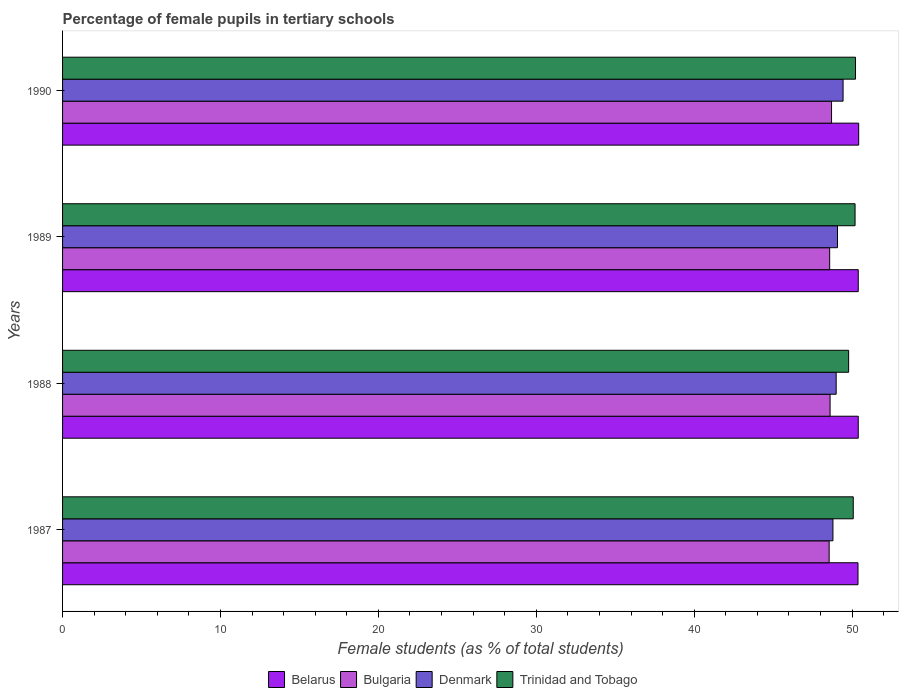How many different coloured bars are there?
Make the answer very short. 4. How many groups of bars are there?
Your answer should be very brief. 4. Are the number of bars on each tick of the Y-axis equal?
Your response must be concise. Yes. How many bars are there on the 4th tick from the top?
Provide a succinct answer. 4. What is the label of the 2nd group of bars from the top?
Offer a terse response. 1989. What is the percentage of female pupils in tertiary schools in Denmark in 1989?
Your response must be concise. 49.07. Across all years, what is the maximum percentage of female pupils in tertiary schools in Denmark?
Offer a very short reply. 49.43. Across all years, what is the minimum percentage of female pupils in tertiary schools in Denmark?
Keep it short and to the point. 48.79. In which year was the percentage of female pupils in tertiary schools in Belarus minimum?
Ensure brevity in your answer.  1987. What is the total percentage of female pupils in tertiary schools in Belarus in the graph?
Offer a very short reply. 201.57. What is the difference between the percentage of female pupils in tertiary schools in Denmark in 1988 and that in 1989?
Make the answer very short. -0.08. What is the difference between the percentage of female pupils in tertiary schools in Trinidad and Tobago in 1987 and the percentage of female pupils in tertiary schools in Bulgaria in 1988?
Keep it short and to the point. 1.47. What is the average percentage of female pupils in tertiary schools in Trinidad and Tobago per year?
Keep it short and to the point. 50.06. In the year 1988, what is the difference between the percentage of female pupils in tertiary schools in Denmark and percentage of female pupils in tertiary schools in Trinidad and Tobago?
Provide a short and direct response. -0.79. What is the ratio of the percentage of female pupils in tertiary schools in Belarus in 1989 to that in 1990?
Your response must be concise. 1. Is the percentage of female pupils in tertiary schools in Belarus in 1989 less than that in 1990?
Offer a very short reply. Yes. What is the difference between the highest and the second highest percentage of female pupils in tertiary schools in Bulgaria?
Give a very brief answer. 0.09. What is the difference between the highest and the lowest percentage of female pupils in tertiary schools in Belarus?
Ensure brevity in your answer.  0.04. Is it the case that in every year, the sum of the percentage of female pupils in tertiary schools in Belarus and percentage of female pupils in tertiary schools in Trinidad and Tobago is greater than the sum of percentage of female pupils in tertiary schools in Denmark and percentage of female pupils in tertiary schools in Bulgaria?
Offer a terse response. No. What does the 4th bar from the top in 1990 represents?
Your answer should be very brief. Belarus. What does the 1st bar from the bottom in 1987 represents?
Your answer should be very brief. Belarus. Is it the case that in every year, the sum of the percentage of female pupils in tertiary schools in Belarus and percentage of female pupils in tertiary schools in Trinidad and Tobago is greater than the percentage of female pupils in tertiary schools in Bulgaria?
Give a very brief answer. Yes. How many bars are there?
Your answer should be very brief. 16. Are all the bars in the graph horizontal?
Offer a very short reply. Yes. How many years are there in the graph?
Provide a short and direct response. 4. What is the difference between two consecutive major ticks on the X-axis?
Make the answer very short. 10. Are the values on the major ticks of X-axis written in scientific E-notation?
Your answer should be very brief. No. Does the graph contain any zero values?
Your answer should be very brief. No. Does the graph contain grids?
Your response must be concise. No. What is the title of the graph?
Provide a short and direct response. Percentage of female pupils in tertiary schools. What is the label or title of the X-axis?
Provide a succinct answer. Female students (as % of total students). What is the label or title of the Y-axis?
Provide a short and direct response. Years. What is the Female students (as % of total students) of Belarus in 1987?
Your answer should be compact. 50.37. What is the Female students (as % of total students) of Bulgaria in 1987?
Your answer should be compact. 48.55. What is the Female students (as % of total students) in Denmark in 1987?
Offer a very short reply. 48.79. What is the Female students (as % of total students) in Trinidad and Tobago in 1987?
Make the answer very short. 50.07. What is the Female students (as % of total students) in Belarus in 1988?
Keep it short and to the point. 50.39. What is the Female students (as % of total students) of Bulgaria in 1988?
Keep it short and to the point. 48.6. What is the Female students (as % of total students) of Denmark in 1988?
Offer a terse response. 48.99. What is the Female students (as % of total students) in Trinidad and Tobago in 1988?
Your answer should be compact. 49.78. What is the Female students (as % of total students) in Belarus in 1989?
Your response must be concise. 50.39. What is the Female students (as % of total students) in Bulgaria in 1989?
Give a very brief answer. 48.58. What is the Female students (as % of total students) of Denmark in 1989?
Offer a very short reply. 49.07. What is the Female students (as % of total students) of Trinidad and Tobago in 1989?
Ensure brevity in your answer.  50.19. What is the Female students (as % of total students) in Belarus in 1990?
Your response must be concise. 50.42. What is the Female students (as % of total students) of Bulgaria in 1990?
Your answer should be compact. 48.7. What is the Female students (as % of total students) in Denmark in 1990?
Give a very brief answer. 49.43. What is the Female students (as % of total students) in Trinidad and Tobago in 1990?
Offer a terse response. 50.22. Across all years, what is the maximum Female students (as % of total students) of Belarus?
Provide a short and direct response. 50.42. Across all years, what is the maximum Female students (as % of total students) of Bulgaria?
Ensure brevity in your answer.  48.7. Across all years, what is the maximum Female students (as % of total students) of Denmark?
Your response must be concise. 49.43. Across all years, what is the maximum Female students (as % of total students) in Trinidad and Tobago?
Keep it short and to the point. 50.22. Across all years, what is the minimum Female students (as % of total students) of Belarus?
Keep it short and to the point. 50.37. Across all years, what is the minimum Female students (as % of total students) in Bulgaria?
Provide a short and direct response. 48.55. Across all years, what is the minimum Female students (as % of total students) of Denmark?
Make the answer very short. 48.79. Across all years, what is the minimum Female students (as % of total students) in Trinidad and Tobago?
Provide a short and direct response. 49.78. What is the total Female students (as % of total students) in Belarus in the graph?
Keep it short and to the point. 201.57. What is the total Female students (as % of total students) of Bulgaria in the graph?
Provide a short and direct response. 194.43. What is the total Female students (as % of total students) in Denmark in the graph?
Offer a terse response. 196.28. What is the total Female students (as % of total students) of Trinidad and Tobago in the graph?
Your response must be concise. 200.25. What is the difference between the Female students (as % of total students) in Belarus in 1987 and that in 1988?
Keep it short and to the point. -0.02. What is the difference between the Female students (as % of total students) in Bulgaria in 1987 and that in 1988?
Your answer should be very brief. -0.06. What is the difference between the Female students (as % of total students) of Denmark in 1987 and that in 1988?
Provide a short and direct response. -0.2. What is the difference between the Female students (as % of total students) in Trinidad and Tobago in 1987 and that in 1988?
Offer a very short reply. 0.29. What is the difference between the Female students (as % of total students) of Belarus in 1987 and that in 1989?
Keep it short and to the point. -0.02. What is the difference between the Female students (as % of total students) of Bulgaria in 1987 and that in 1989?
Your answer should be compact. -0.03. What is the difference between the Female students (as % of total students) of Denmark in 1987 and that in 1989?
Give a very brief answer. -0.29. What is the difference between the Female students (as % of total students) in Trinidad and Tobago in 1987 and that in 1989?
Your answer should be very brief. -0.12. What is the difference between the Female students (as % of total students) of Belarus in 1987 and that in 1990?
Your answer should be compact. -0.04. What is the difference between the Female students (as % of total students) of Bulgaria in 1987 and that in 1990?
Provide a short and direct response. -0.15. What is the difference between the Female students (as % of total students) of Denmark in 1987 and that in 1990?
Your answer should be very brief. -0.64. What is the difference between the Female students (as % of total students) of Trinidad and Tobago in 1987 and that in 1990?
Offer a very short reply. -0.14. What is the difference between the Female students (as % of total students) in Belarus in 1988 and that in 1989?
Make the answer very short. -0. What is the difference between the Female students (as % of total students) in Bulgaria in 1988 and that in 1989?
Provide a short and direct response. 0.03. What is the difference between the Female students (as % of total students) of Denmark in 1988 and that in 1989?
Ensure brevity in your answer.  -0.08. What is the difference between the Female students (as % of total students) in Trinidad and Tobago in 1988 and that in 1989?
Provide a succinct answer. -0.41. What is the difference between the Female students (as % of total students) in Belarus in 1988 and that in 1990?
Give a very brief answer. -0.03. What is the difference between the Female students (as % of total students) in Bulgaria in 1988 and that in 1990?
Ensure brevity in your answer.  -0.09. What is the difference between the Female students (as % of total students) of Denmark in 1988 and that in 1990?
Provide a succinct answer. -0.44. What is the difference between the Female students (as % of total students) in Trinidad and Tobago in 1988 and that in 1990?
Provide a short and direct response. -0.44. What is the difference between the Female students (as % of total students) in Belarus in 1989 and that in 1990?
Your answer should be very brief. -0.03. What is the difference between the Female students (as % of total students) in Bulgaria in 1989 and that in 1990?
Keep it short and to the point. -0.12. What is the difference between the Female students (as % of total students) of Denmark in 1989 and that in 1990?
Provide a succinct answer. -0.35. What is the difference between the Female students (as % of total students) of Trinidad and Tobago in 1989 and that in 1990?
Keep it short and to the point. -0.03. What is the difference between the Female students (as % of total students) of Belarus in 1987 and the Female students (as % of total students) of Bulgaria in 1988?
Give a very brief answer. 1.77. What is the difference between the Female students (as % of total students) in Belarus in 1987 and the Female students (as % of total students) in Denmark in 1988?
Provide a succinct answer. 1.38. What is the difference between the Female students (as % of total students) in Belarus in 1987 and the Female students (as % of total students) in Trinidad and Tobago in 1988?
Offer a very short reply. 0.59. What is the difference between the Female students (as % of total students) in Bulgaria in 1987 and the Female students (as % of total students) in Denmark in 1988?
Make the answer very short. -0.44. What is the difference between the Female students (as % of total students) in Bulgaria in 1987 and the Female students (as % of total students) in Trinidad and Tobago in 1988?
Give a very brief answer. -1.23. What is the difference between the Female students (as % of total students) of Denmark in 1987 and the Female students (as % of total students) of Trinidad and Tobago in 1988?
Your response must be concise. -0.99. What is the difference between the Female students (as % of total students) of Belarus in 1987 and the Female students (as % of total students) of Bulgaria in 1989?
Your answer should be very brief. 1.79. What is the difference between the Female students (as % of total students) in Belarus in 1987 and the Female students (as % of total students) in Denmark in 1989?
Keep it short and to the point. 1.3. What is the difference between the Female students (as % of total students) in Belarus in 1987 and the Female students (as % of total students) in Trinidad and Tobago in 1989?
Provide a short and direct response. 0.19. What is the difference between the Female students (as % of total students) of Bulgaria in 1987 and the Female students (as % of total students) of Denmark in 1989?
Your answer should be very brief. -0.53. What is the difference between the Female students (as % of total students) in Bulgaria in 1987 and the Female students (as % of total students) in Trinidad and Tobago in 1989?
Ensure brevity in your answer.  -1.64. What is the difference between the Female students (as % of total students) of Denmark in 1987 and the Female students (as % of total students) of Trinidad and Tobago in 1989?
Your answer should be very brief. -1.4. What is the difference between the Female students (as % of total students) in Belarus in 1987 and the Female students (as % of total students) in Bulgaria in 1990?
Make the answer very short. 1.68. What is the difference between the Female students (as % of total students) in Belarus in 1987 and the Female students (as % of total students) in Denmark in 1990?
Give a very brief answer. 0.94. What is the difference between the Female students (as % of total students) of Belarus in 1987 and the Female students (as % of total students) of Trinidad and Tobago in 1990?
Provide a succinct answer. 0.16. What is the difference between the Female students (as % of total students) in Bulgaria in 1987 and the Female students (as % of total students) in Denmark in 1990?
Your response must be concise. -0.88. What is the difference between the Female students (as % of total students) in Bulgaria in 1987 and the Female students (as % of total students) in Trinidad and Tobago in 1990?
Keep it short and to the point. -1.67. What is the difference between the Female students (as % of total students) of Denmark in 1987 and the Female students (as % of total students) of Trinidad and Tobago in 1990?
Give a very brief answer. -1.43. What is the difference between the Female students (as % of total students) of Belarus in 1988 and the Female students (as % of total students) of Bulgaria in 1989?
Offer a terse response. 1.81. What is the difference between the Female students (as % of total students) in Belarus in 1988 and the Female students (as % of total students) in Denmark in 1989?
Your response must be concise. 1.31. What is the difference between the Female students (as % of total students) of Belarus in 1988 and the Female students (as % of total students) of Trinidad and Tobago in 1989?
Your answer should be very brief. 0.2. What is the difference between the Female students (as % of total students) of Bulgaria in 1988 and the Female students (as % of total students) of Denmark in 1989?
Offer a very short reply. -0.47. What is the difference between the Female students (as % of total students) of Bulgaria in 1988 and the Female students (as % of total students) of Trinidad and Tobago in 1989?
Offer a terse response. -1.58. What is the difference between the Female students (as % of total students) of Denmark in 1988 and the Female students (as % of total students) of Trinidad and Tobago in 1989?
Make the answer very short. -1.2. What is the difference between the Female students (as % of total students) of Belarus in 1988 and the Female students (as % of total students) of Bulgaria in 1990?
Provide a succinct answer. 1.69. What is the difference between the Female students (as % of total students) of Belarus in 1988 and the Female students (as % of total students) of Denmark in 1990?
Your answer should be very brief. 0.96. What is the difference between the Female students (as % of total students) of Belarus in 1988 and the Female students (as % of total students) of Trinidad and Tobago in 1990?
Keep it short and to the point. 0.17. What is the difference between the Female students (as % of total students) of Bulgaria in 1988 and the Female students (as % of total students) of Denmark in 1990?
Offer a very short reply. -0.82. What is the difference between the Female students (as % of total students) of Bulgaria in 1988 and the Female students (as % of total students) of Trinidad and Tobago in 1990?
Provide a short and direct response. -1.61. What is the difference between the Female students (as % of total students) of Denmark in 1988 and the Female students (as % of total students) of Trinidad and Tobago in 1990?
Your response must be concise. -1.23. What is the difference between the Female students (as % of total students) of Belarus in 1989 and the Female students (as % of total students) of Bulgaria in 1990?
Ensure brevity in your answer.  1.69. What is the difference between the Female students (as % of total students) of Belarus in 1989 and the Female students (as % of total students) of Denmark in 1990?
Ensure brevity in your answer.  0.96. What is the difference between the Female students (as % of total students) of Belarus in 1989 and the Female students (as % of total students) of Trinidad and Tobago in 1990?
Offer a very short reply. 0.17. What is the difference between the Female students (as % of total students) of Bulgaria in 1989 and the Female students (as % of total students) of Denmark in 1990?
Give a very brief answer. -0.85. What is the difference between the Female students (as % of total students) of Bulgaria in 1989 and the Female students (as % of total students) of Trinidad and Tobago in 1990?
Your answer should be very brief. -1.64. What is the difference between the Female students (as % of total students) of Denmark in 1989 and the Female students (as % of total students) of Trinidad and Tobago in 1990?
Make the answer very short. -1.14. What is the average Female students (as % of total students) in Belarus per year?
Your answer should be compact. 50.39. What is the average Female students (as % of total students) of Bulgaria per year?
Your response must be concise. 48.61. What is the average Female students (as % of total students) of Denmark per year?
Your answer should be very brief. 49.07. What is the average Female students (as % of total students) in Trinidad and Tobago per year?
Give a very brief answer. 50.06. In the year 1987, what is the difference between the Female students (as % of total students) in Belarus and Female students (as % of total students) in Bulgaria?
Make the answer very short. 1.83. In the year 1987, what is the difference between the Female students (as % of total students) of Belarus and Female students (as % of total students) of Denmark?
Keep it short and to the point. 1.59. In the year 1987, what is the difference between the Female students (as % of total students) of Belarus and Female students (as % of total students) of Trinidad and Tobago?
Ensure brevity in your answer.  0.3. In the year 1987, what is the difference between the Female students (as % of total students) in Bulgaria and Female students (as % of total students) in Denmark?
Ensure brevity in your answer.  -0.24. In the year 1987, what is the difference between the Female students (as % of total students) in Bulgaria and Female students (as % of total students) in Trinidad and Tobago?
Ensure brevity in your answer.  -1.53. In the year 1987, what is the difference between the Female students (as % of total students) of Denmark and Female students (as % of total students) of Trinidad and Tobago?
Provide a succinct answer. -1.29. In the year 1988, what is the difference between the Female students (as % of total students) of Belarus and Female students (as % of total students) of Bulgaria?
Give a very brief answer. 1.78. In the year 1988, what is the difference between the Female students (as % of total students) in Belarus and Female students (as % of total students) in Denmark?
Keep it short and to the point. 1.4. In the year 1988, what is the difference between the Female students (as % of total students) of Belarus and Female students (as % of total students) of Trinidad and Tobago?
Your answer should be compact. 0.61. In the year 1988, what is the difference between the Female students (as % of total students) of Bulgaria and Female students (as % of total students) of Denmark?
Keep it short and to the point. -0.39. In the year 1988, what is the difference between the Female students (as % of total students) in Bulgaria and Female students (as % of total students) in Trinidad and Tobago?
Make the answer very short. -1.18. In the year 1988, what is the difference between the Female students (as % of total students) in Denmark and Female students (as % of total students) in Trinidad and Tobago?
Your response must be concise. -0.79. In the year 1989, what is the difference between the Female students (as % of total students) of Belarus and Female students (as % of total students) of Bulgaria?
Ensure brevity in your answer.  1.81. In the year 1989, what is the difference between the Female students (as % of total students) in Belarus and Female students (as % of total students) in Denmark?
Your response must be concise. 1.31. In the year 1989, what is the difference between the Female students (as % of total students) in Belarus and Female students (as % of total students) in Trinidad and Tobago?
Offer a terse response. 0.2. In the year 1989, what is the difference between the Female students (as % of total students) in Bulgaria and Female students (as % of total students) in Denmark?
Provide a succinct answer. -0.5. In the year 1989, what is the difference between the Female students (as % of total students) of Bulgaria and Female students (as % of total students) of Trinidad and Tobago?
Provide a short and direct response. -1.61. In the year 1989, what is the difference between the Female students (as % of total students) in Denmark and Female students (as % of total students) in Trinidad and Tobago?
Keep it short and to the point. -1.11. In the year 1990, what is the difference between the Female students (as % of total students) of Belarus and Female students (as % of total students) of Bulgaria?
Your answer should be very brief. 1.72. In the year 1990, what is the difference between the Female students (as % of total students) in Belarus and Female students (as % of total students) in Denmark?
Offer a very short reply. 0.99. In the year 1990, what is the difference between the Female students (as % of total students) in Belarus and Female students (as % of total students) in Trinidad and Tobago?
Give a very brief answer. 0.2. In the year 1990, what is the difference between the Female students (as % of total students) in Bulgaria and Female students (as % of total students) in Denmark?
Your response must be concise. -0.73. In the year 1990, what is the difference between the Female students (as % of total students) of Bulgaria and Female students (as % of total students) of Trinidad and Tobago?
Offer a terse response. -1.52. In the year 1990, what is the difference between the Female students (as % of total students) in Denmark and Female students (as % of total students) in Trinidad and Tobago?
Provide a short and direct response. -0.79. What is the ratio of the Female students (as % of total students) in Belarus in 1987 to that in 1988?
Offer a very short reply. 1. What is the ratio of the Female students (as % of total students) in Bulgaria in 1987 to that in 1988?
Provide a short and direct response. 1. What is the ratio of the Female students (as % of total students) in Trinidad and Tobago in 1987 to that in 1988?
Provide a succinct answer. 1.01. What is the ratio of the Female students (as % of total students) of Bulgaria in 1987 to that in 1989?
Your response must be concise. 1. What is the ratio of the Female students (as % of total students) of Trinidad and Tobago in 1987 to that in 1989?
Make the answer very short. 1. What is the ratio of the Female students (as % of total students) in Belarus in 1987 to that in 1990?
Make the answer very short. 1. What is the ratio of the Female students (as % of total students) of Bulgaria in 1987 to that in 1990?
Keep it short and to the point. 1. What is the ratio of the Female students (as % of total students) in Denmark in 1987 to that in 1990?
Your response must be concise. 0.99. What is the ratio of the Female students (as % of total students) in Trinidad and Tobago in 1987 to that in 1990?
Make the answer very short. 1. What is the ratio of the Female students (as % of total students) of Trinidad and Tobago in 1988 to that in 1989?
Your answer should be very brief. 0.99. What is the ratio of the Female students (as % of total students) of Belarus in 1988 to that in 1990?
Keep it short and to the point. 1. What is the ratio of the Female students (as % of total students) of Denmark in 1988 to that in 1990?
Your answer should be compact. 0.99. What is the ratio of the Female students (as % of total students) of Bulgaria in 1989 to that in 1990?
Your answer should be compact. 1. What is the ratio of the Female students (as % of total students) in Denmark in 1989 to that in 1990?
Provide a succinct answer. 0.99. What is the ratio of the Female students (as % of total students) in Trinidad and Tobago in 1989 to that in 1990?
Your answer should be compact. 1. What is the difference between the highest and the second highest Female students (as % of total students) in Belarus?
Make the answer very short. 0.03. What is the difference between the highest and the second highest Female students (as % of total students) of Bulgaria?
Provide a succinct answer. 0.09. What is the difference between the highest and the second highest Female students (as % of total students) in Denmark?
Offer a very short reply. 0.35. What is the difference between the highest and the second highest Female students (as % of total students) in Trinidad and Tobago?
Offer a terse response. 0.03. What is the difference between the highest and the lowest Female students (as % of total students) of Belarus?
Provide a succinct answer. 0.04. What is the difference between the highest and the lowest Female students (as % of total students) in Bulgaria?
Your answer should be very brief. 0.15. What is the difference between the highest and the lowest Female students (as % of total students) of Denmark?
Give a very brief answer. 0.64. What is the difference between the highest and the lowest Female students (as % of total students) in Trinidad and Tobago?
Your response must be concise. 0.44. 